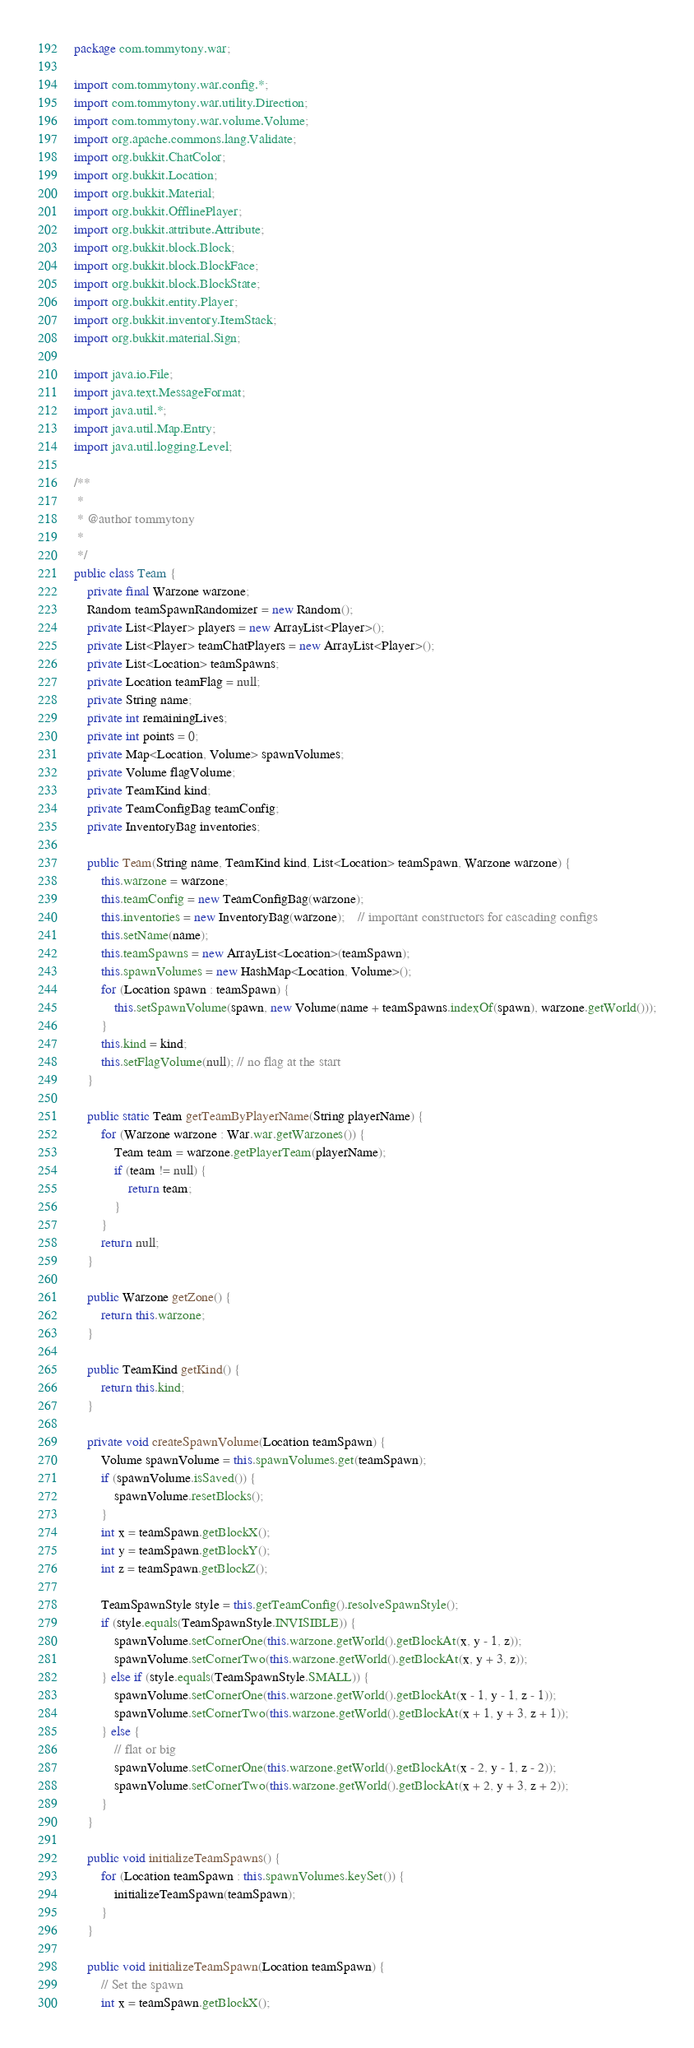Convert code to text. <code><loc_0><loc_0><loc_500><loc_500><_Java_>package com.tommytony.war;

import com.tommytony.war.config.*;
import com.tommytony.war.utility.Direction;
import com.tommytony.war.volume.Volume;
import org.apache.commons.lang.Validate;
import org.bukkit.ChatColor;
import org.bukkit.Location;
import org.bukkit.Material;
import org.bukkit.OfflinePlayer;
import org.bukkit.attribute.Attribute;
import org.bukkit.block.Block;
import org.bukkit.block.BlockFace;
import org.bukkit.block.BlockState;
import org.bukkit.entity.Player;
import org.bukkit.inventory.ItemStack;
import org.bukkit.material.Sign;

import java.io.File;
import java.text.MessageFormat;
import java.util.*;
import java.util.Map.Entry;
import java.util.logging.Level;

/**
 *
 * @author tommytony
 *
 */
public class Team {
	private final Warzone warzone;
	Random teamSpawnRandomizer = new Random();
	private List<Player> players = new ArrayList<Player>();
	private List<Player> teamChatPlayers = new ArrayList<Player>();
	private List<Location> teamSpawns;
	private Location teamFlag = null;
	private String name;
	private int remainingLives;
	private int points = 0;
	private Map<Location, Volume> spawnVolumes;
	private Volume flagVolume;
	private TeamKind kind;
	private TeamConfigBag teamConfig;
	private InventoryBag inventories;

	public Team(String name, TeamKind kind, List<Location> teamSpawn, Warzone warzone) {
		this.warzone = warzone;
		this.teamConfig = new TeamConfigBag(warzone);
		this.inventories = new InventoryBag(warzone);	// important constructors for cascading configs
		this.setName(name);
		this.teamSpawns = new ArrayList<Location>(teamSpawn);
		this.spawnVolumes = new HashMap<Location, Volume>();
		for (Location spawn : teamSpawn) {
			this.setSpawnVolume(spawn, new Volume(name + teamSpawns.indexOf(spawn), warzone.getWorld()));
		}
		this.kind = kind;
		this.setFlagVolume(null); // no flag at the start
	}

	public static Team getTeamByPlayerName(String playerName) {
		for (Warzone warzone : War.war.getWarzones()) {
			Team team = warzone.getPlayerTeam(playerName);
			if (team != null) {
				return team;
			}
		}
		return null;
	}

	public Warzone getZone() {
		return this.warzone;
	}

	public TeamKind getKind() {
		return this.kind;
	}

	private void createSpawnVolume(Location teamSpawn) {
		Volume spawnVolume = this.spawnVolumes.get(teamSpawn);
		if (spawnVolume.isSaved()) {
			spawnVolume.resetBlocks();
		}
		int x = teamSpawn.getBlockX();
		int y = teamSpawn.getBlockY();
		int z = teamSpawn.getBlockZ();

		TeamSpawnStyle style = this.getTeamConfig().resolveSpawnStyle();
		if (style.equals(TeamSpawnStyle.INVISIBLE)) {
			spawnVolume.setCornerOne(this.warzone.getWorld().getBlockAt(x, y - 1, z));
			spawnVolume.setCornerTwo(this.warzone.getWorld().getBlockAt(x, y + 3, z));
		} else if (style.equals(TeamSpawnStyle.SMALL)) {
			spawnVolume.setCornerOne(this.warzone.getWorld().getBlockAt(x - 1, y - 1, z - 1));
			spawnVolume.setCornerTwo(this.warzone.getWorld().getBlockAt(x + 1, y + 3, z + 1));
		} else {
			// flat or big
			spawnVolume.setCornerOne(this.warzone.getWorld().getBlockAt(x - 2, y - 1, z - 2));
			spawnVolume.setCornerTwo(this.warzone.getWorld().getBlockAt(x + 2, y + 3, z + 2));
		}
	}

	public void initializeTeamSpawns() {
		for (Location teamSpawn : this.spawnVolumes.keySet()) {
			initializeTeamSpawn(teamSpawn);
		}
	}

	public void initializeTeamSpawn(Location teamSpawn) {
		// Set the spawn
		int x = teamSpawn.getBlockX();</code> 